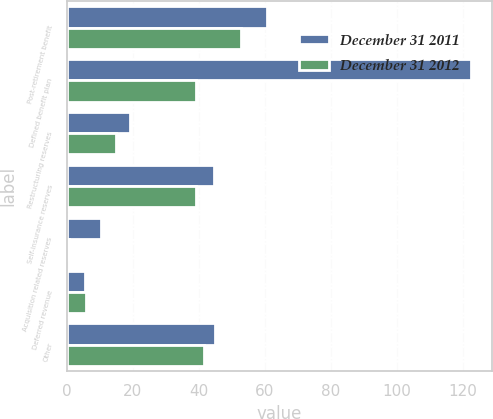Convert chart to OTSL. <chart><loc_0><loc_0><loc_500><loc_500><stacked_bar_chart><ecel><fcel>Post-retirement benefit<fcel>Defined benefit plan<fcel>Restructuring reserves<fcel>Self-insurance reserves<fcel>Acquisition related reserves<fcel>Deferred revenue<fcel>Other<nl><fcel>December 31 2011<fcel>60.7<fcel>122.5<fcel>19.2<fcel>44.5<fcel>10.2<fcel>5.4<fcel>44.9<nl><fcel>December 31 2012<fcel>52.7<fcel>39<fcel>15<fcel>39<fcel>0.6<fcel>5.9<fcel>41.4<nl></chart> 